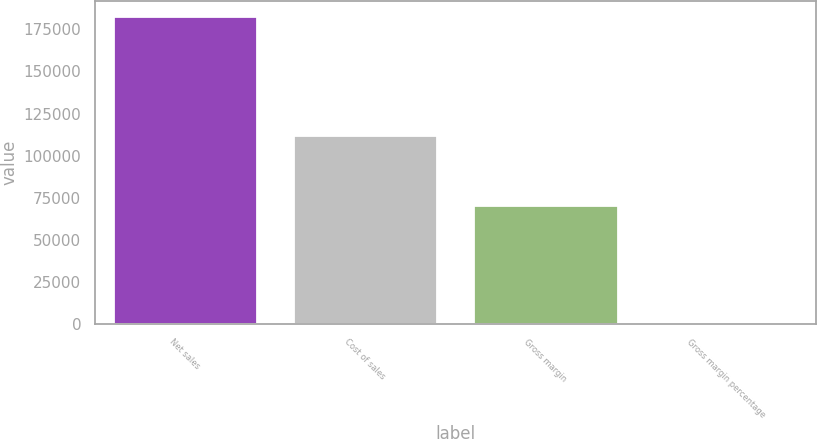Convert chart. <chart><loc_0><loc_0><loc_500><loc_500><bar_chart><fcel>Net sales<fcel>Cost of sales<fcel>Gross margin<fcel>Gross margin percentage<nl><fcel>182795<fcel>112258<fcel>70537<fcel>38.6<nl></chart> 